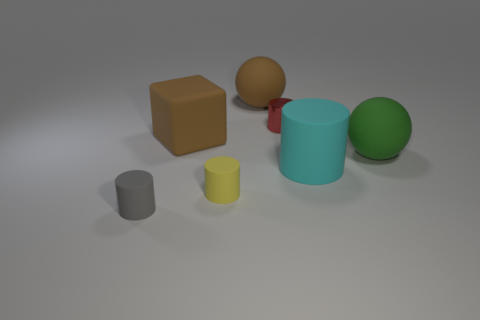Subtract all small gray cylinders. How many cylinders are left? 3 Add 2 large cyan cylinders. How many objects exist? 9 Subtract all red cylinders. How many cylinders are left? 3 Subtract all big yellow matte spheres. Subtract all small gray matte cylinders. How many objects are left? 6 Add 3 brown matte spheres. How many brown matte spheres are left? 4 Add 4 metallic cylinders. How many metallic cylinders exist? 5 Subtract 1 yellow cylinders. How many objects are left? 6 Subtract all cubes. How many objects are left? 6 Subtract all red spheres. Subtract all yellow blocks. How many spheres are left? 2 Subtract all blue spheres. How many red cylinders are left? 1 